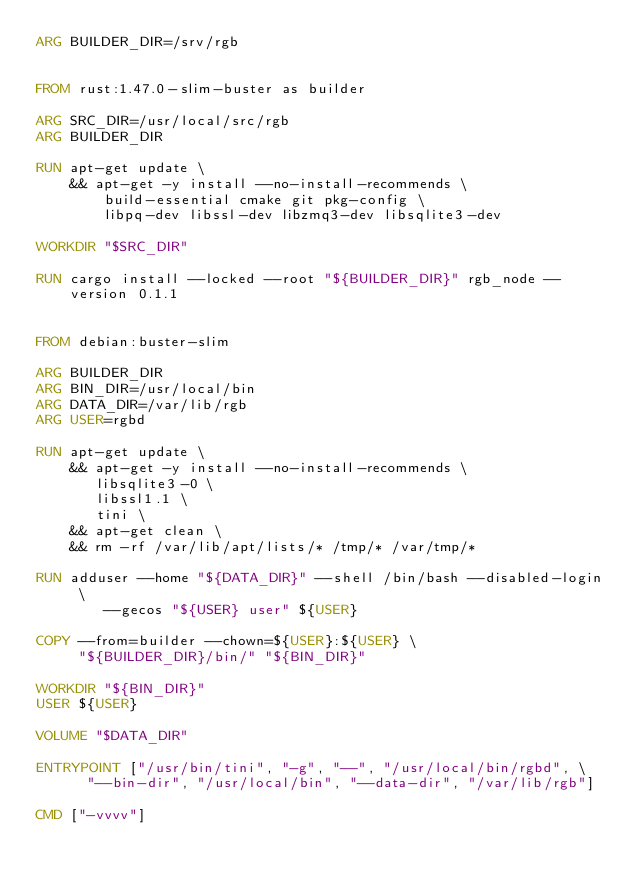Convert code to text. <code><loc_0><loc_0><loc_500><loc_500><_Dockerfile_>ARG BUILDER_DIR=/srv/rgb


FROM rust:1.47.0-slim-buster as builder

ARG SRC_DIR=/usr/local/src/rgb
ARG BUILDER_DIR

RUN apt-get update \
    && apt-get -y install --no-install-recommends \
        build-essential cmake git pkg-config \
        libpq-dev libssl-dev libzmq3-dev libsqlite3-dev

WORKDIR "$SRC_DIR"

RUN cargo install --locked --root "${BUILDER_DIR}" rgb_node --version 0.1.1


FROM debian:buster-slim

ARG BUILDER_DIR
ARG BIN_DIR=/usr/local/bin
ARG DATA_DIR=/var/lib/rgb
ARG USER=rgbd

RUN apt-get update \
    && apt-get -y install --no-install-recommends \
       libsqlite3-0 \
       libssl1.1 \
       tini \
    && apt-get clean \
    && rm -rf /var/lib/apt/lists/* /tmp/* /var/tmp/*

RUN adduser --home "${DATA_DIR}" --shell /bin/bash --disabled-login \
        --gecos "${USER} user" ${USER}

COPY --from=builder --chown=${USER}:${USER} \
     "${BUILDER_DIR}/bin/" "${BIN_DIR}"

WORKDIR "${BIN_DIR}"
USER ${USER}

VOLUME "$DATA_DIR"

ENTRYPOINT ["/usr/bin/tini", "-g", "--", "/usr/local/bin/rgbd", \
			"--bin-dir", "/usr/local/bin", "--data-dir", "/var/lib/rgb"]

CMD ["-vvvv"]
</code> 